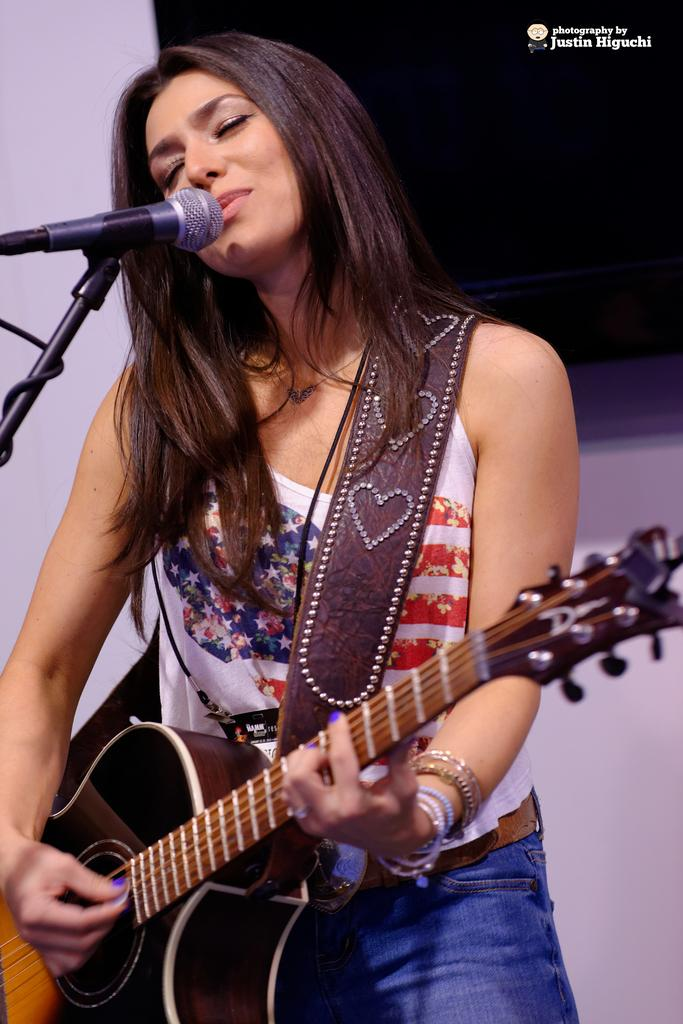Who is the main subject in the image? There is a woman in the image. What is the woman holding in the image? The woman is holding a black music instrument. What is the woman doing with the black microphone? The woman is singing into a black microphone. What type of wilderness can be seen in the background of the image? There is no wilderness visible in the image; it features a woman holding a black music instrument and singing into a black microphone. 